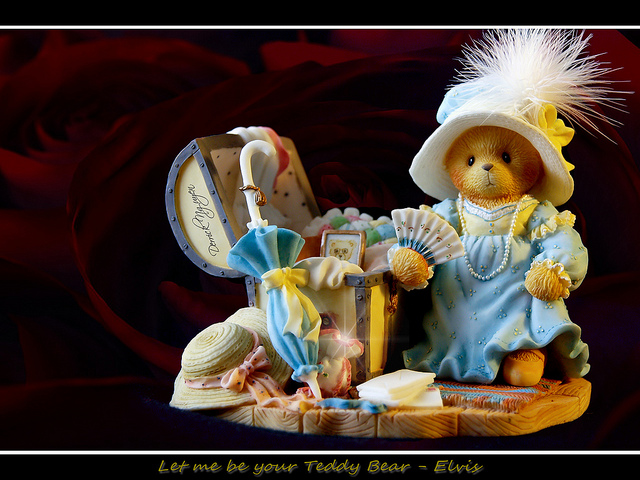Please extract the text content from this image. Let me Be your Teddy Bear Elvis 